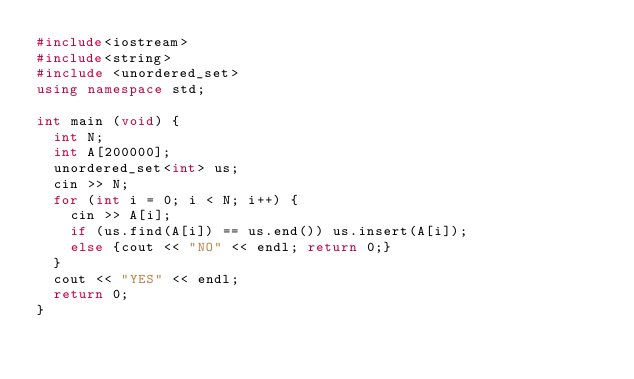Convert code to text. <code><loc_0><loc_0><loc_500><loc_500><_C++_>#include<iostream>
#include<string>
#include <unordered_set>
using namespace std;

int main (void) {
  int N;
  int A[200000];
  unordered_set<int> us;
  cin >> N;
  for (int i = 0; i < N; i++) {
    cin >> A[i];
    if (us.find(A[i]) == us.end()) us.insert(A[i]);
    else {cout << "NO" << endl; return 0;}
  }
  cout << "YES" << endl;
  return 0;
}</code> 